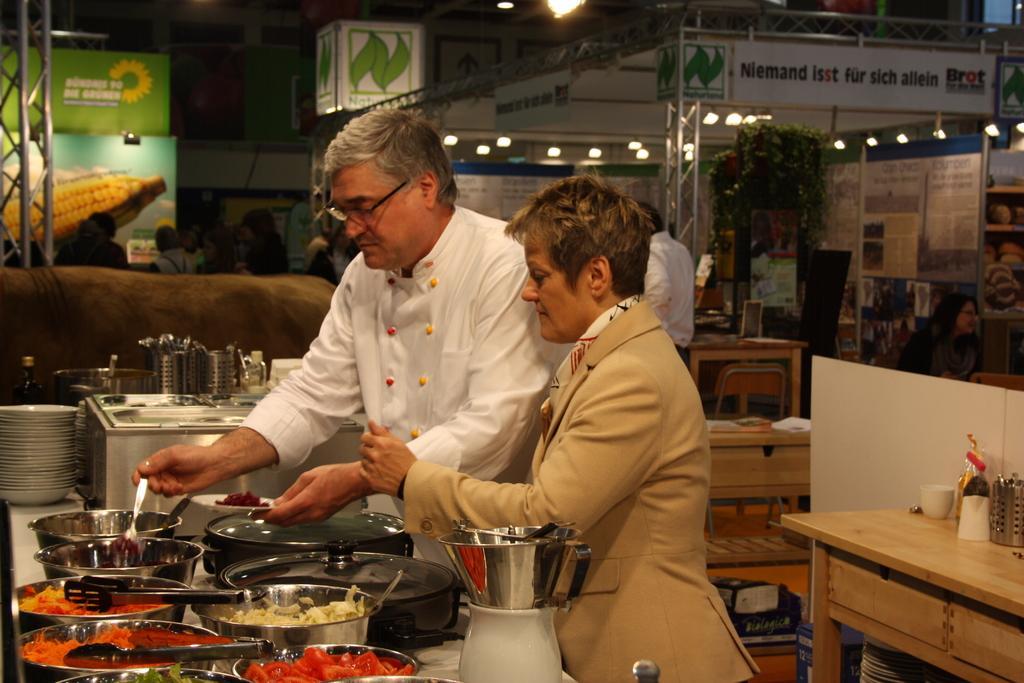Can you describe this image briefly? As we can see in the image there is a current pole, a banner, tree and in the front there are two people standing. In front of them there are bowls, mixer, plates and on the right side there is a table. 